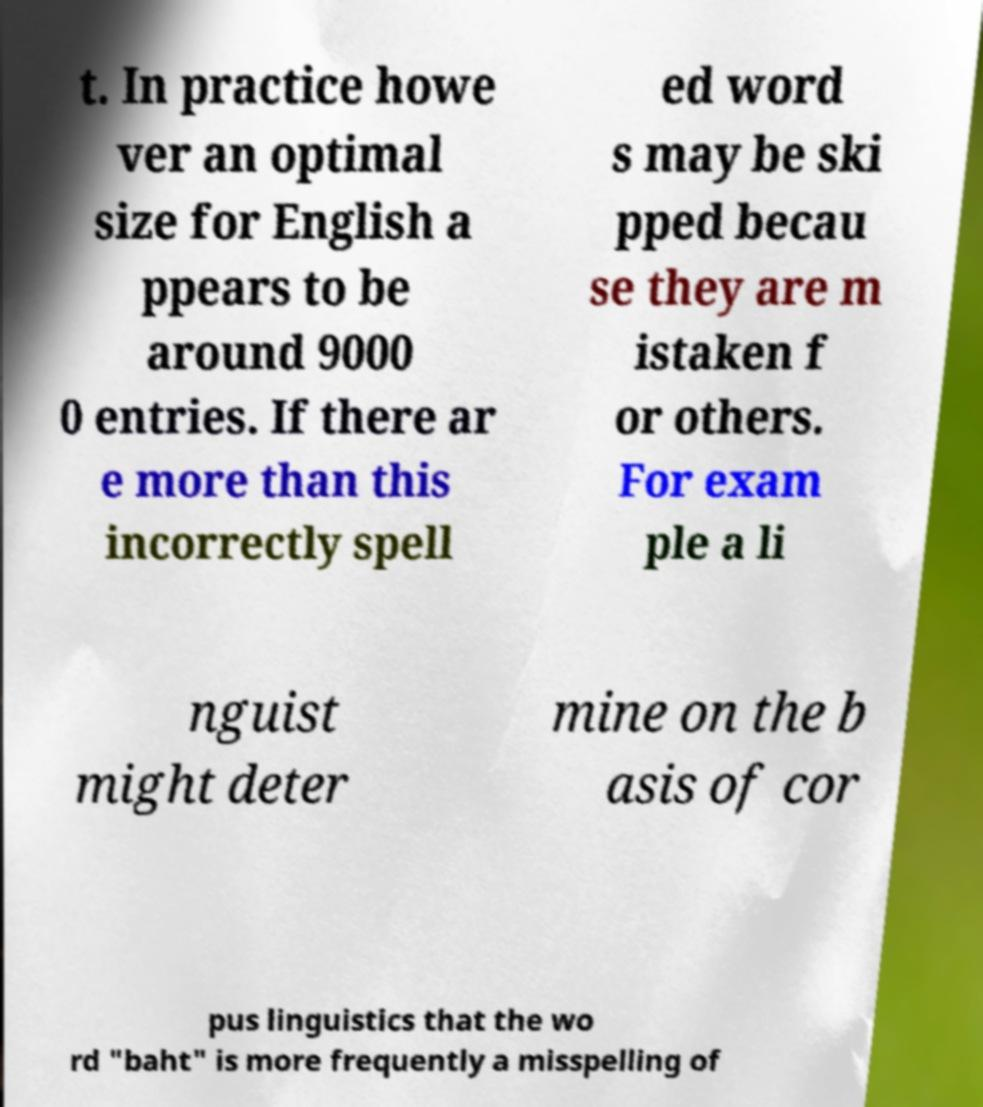Can you read and provide the text displayed in the image?This photo seems to have some interesting text. Can you extract and type it out for me? t. In practice howe ver an optimal size for English a ppears to be around 9000 0 entries. If there ar e more than this incorrectly spell ed word s may be ski pped becau se they are m istaken f or others. For exam ple a li nguist might deter mine on the b asis of cor pus linguistics that the wo rd "baht" is more frequently a misspelling of 